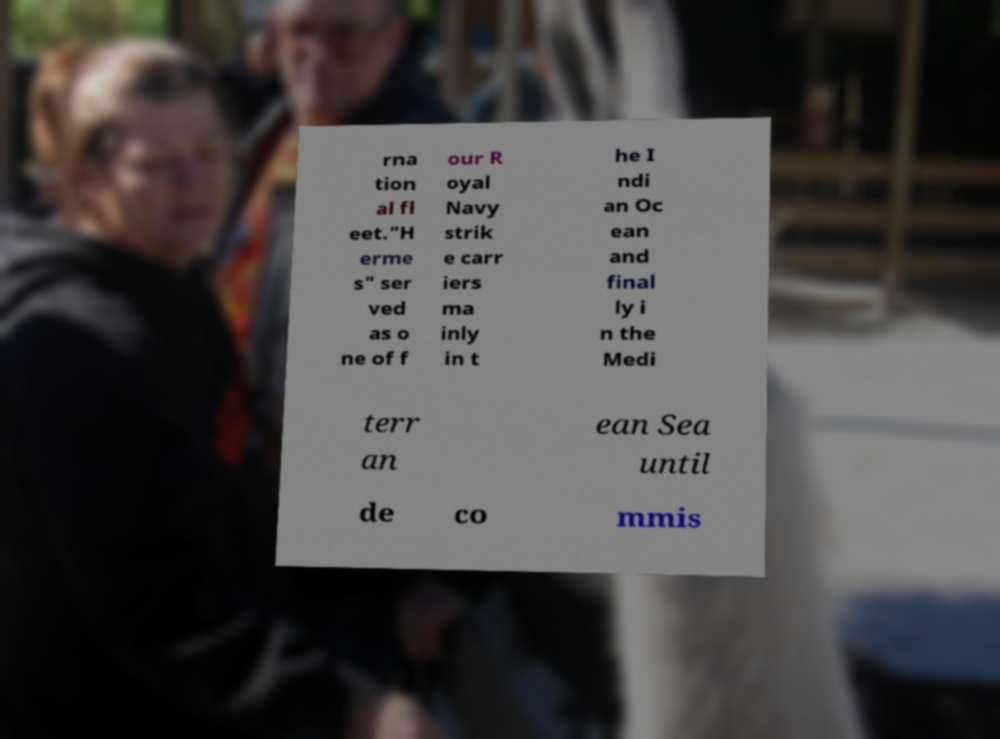I need the written content from this picture converted into text. Can you do that? rna tion al fl eet."H erme s" ser ved as o ne of f our R oyal Navy strik e carr iers ma inly in t he I ndi an Oc ean and final ly i n the Medi terr an ean Sea until de co mmis 